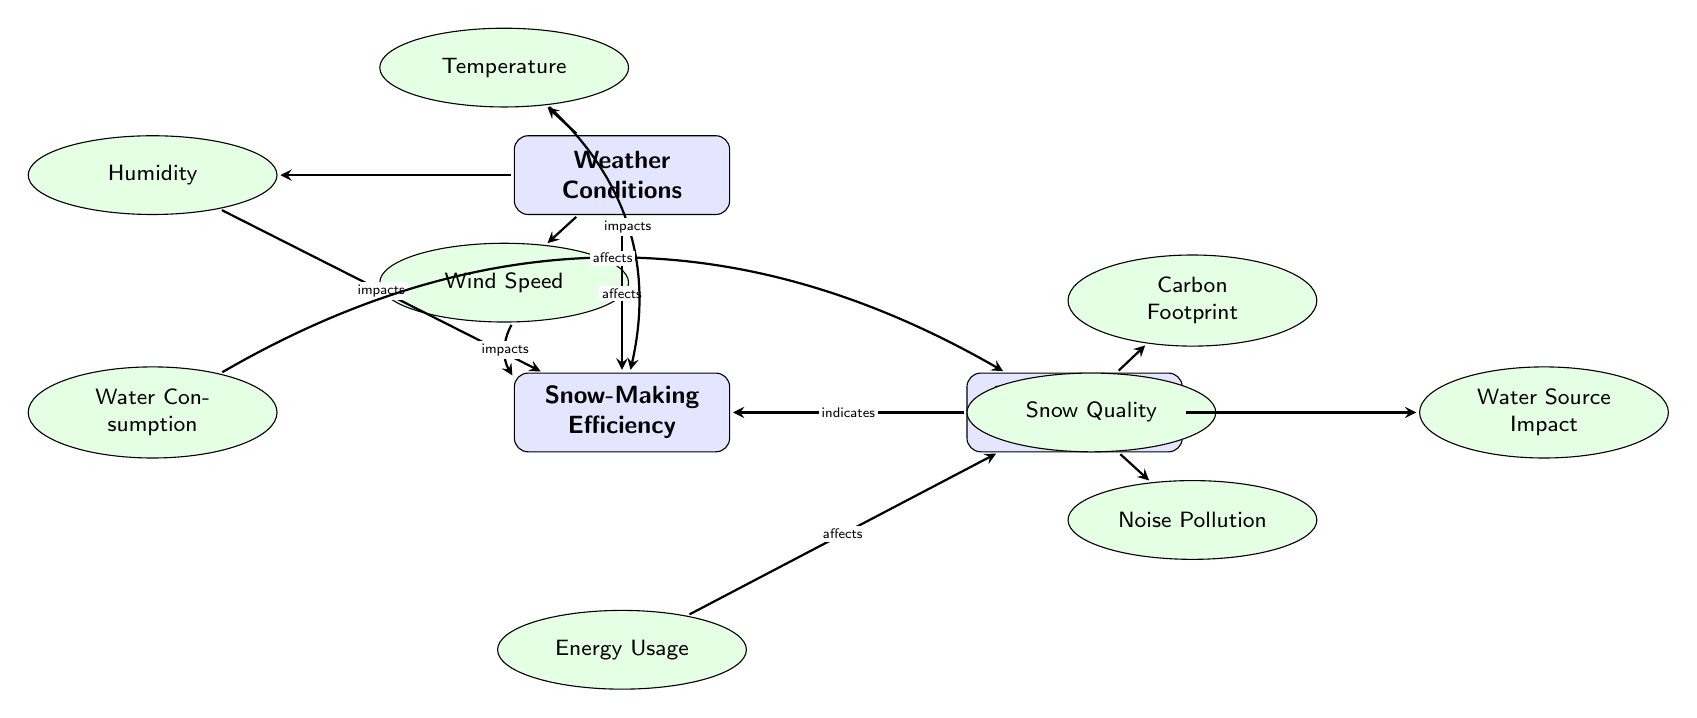What are the three main categories in the diagram? The diagram has three main categories: Weather Conditions, Snow-Making Efficiency, and Environmental Impact. These categories are labeled in rectangular nodes within the diagram.
Answer: Weather Conditions, Snow-Making Efficiency, Environmental Impact How many sub-nodes are under Snow-Making Efficiency? There are three sub-nodes listed under Snow-Making Efficiency: Water Consumption, Energy Usage, and Snow Quality. Each sub-node is an elliptical shape connected to the main Snow-Making Efficiency node.
Answer: 3 Which weather condition directly impacts snow-making efficiency? The diagram shows that Temperature, Humidity, and Wind Speed all impact Snow-Making Efficiency, as indicated by the edges connecting the weather nodes to the efficiency node.
Answer: Temperature, Humidity, Wind Speed What is the relationship between Water Consumption and Environmental Impact? The diagram indicates that Water Consumption affects Environmental Impact, which is represented by a directed edge connecting the Water Consumption node to the Environmental Impact node.
Answer: Affects Which node indicates the quality of snow? The Snow Quality node indicates the quality of snow, and it is connected to the Snow-Making Efficiency node, as shown by an edge labeled "indicates".
Answer: Snow Quality How does wind speed affect snow-making efficiency? Wind speed impacts Snow-Making Efficiency as depicted by the edge from the wind node to the efficiency node. This shows that changes in wind speed can influence how effectively snow is made.
Answer: Impacts What are the three impacts described under Environmental Impact? The diagram outlines three impacts: Carbon Footprint, Water Source Impact, and Noise Pollution. These sub-nodes are indicated as elliptical nodes connected to the Environmental Impact main node.
Answer: Carbon Footprint, Water Source Impact, Noise Pollution Which sub-node under Weather Conditions is positioned below temperature? The Wind Speed node is positioned below Temperature in the layout of the diagram, indicating its relative placement in the structure displaying relationships.
Answer: Wind Speed 